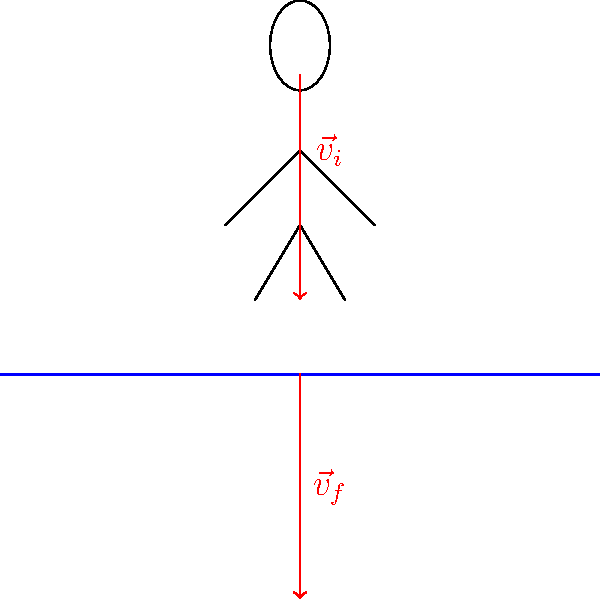A diver enters the water with an initial velocity of 10 m/s. Upon entering the water, they experience a constant deceleration of 20 m/s². If the depth of the pool is 3 meters, what is the diver's velocity when they reach the bottom of the pool? To solve this problem, we'll use the equation of motion that relates velocity, acceleration, and displacement:

$$v_f^2 = v_i^2 + 2a\Delta x$$

Where:
$v_f$ = final velocity (unknown)
$v_i$ = initial velocity = 10 m/s
$a$ = acceleration = -20 m/s² (negative because it's decelerating)
$\Delta x$ = displacement = 3 m

Step 1: Substitute the known values into the equation:
$$v_f^2 = (10 \text{ m/s})^2 + 2(-20 \text{ m/s}^2)(3 \text{ m})$$

Step 2: Simplify:
$$v_f^2 = 100 \text{ m}^2/\text{s}^2 - 120 \text{ m}^2/\text{s}^2$$
$$v_f^2 = -20 \text{ m}^2/\text{s}^2$$

Step 3: Take the square root of both sides:
$$v_f = \sqrt{-20 \text{ m}^2/\text{s}^2}$$
$$v_f = \sqrt{20} \text{ m/s} \approx 4.47 \text{ m/s}$$

The negative solution is discarded as it's not physically meaningful in this context.
Answer: 4.47 m/s 